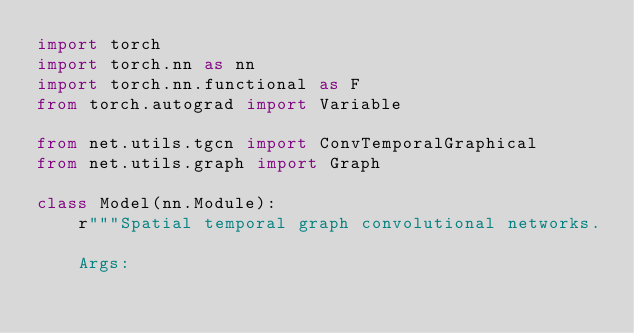Convert code to text. <code><loc_0><loc_0><loc_500><loc_500><_Python_>import torch
import torch.nn as nn
import torch.nn.functional as F
from torch.autograd import Variable

from net.utils.tgcn import ConvTemporalGraphical
from net.utils.graph import Graph

class Model(nn.Module):
    r"""Spatial temporal graph convolutional networks.

    Args:</code> 